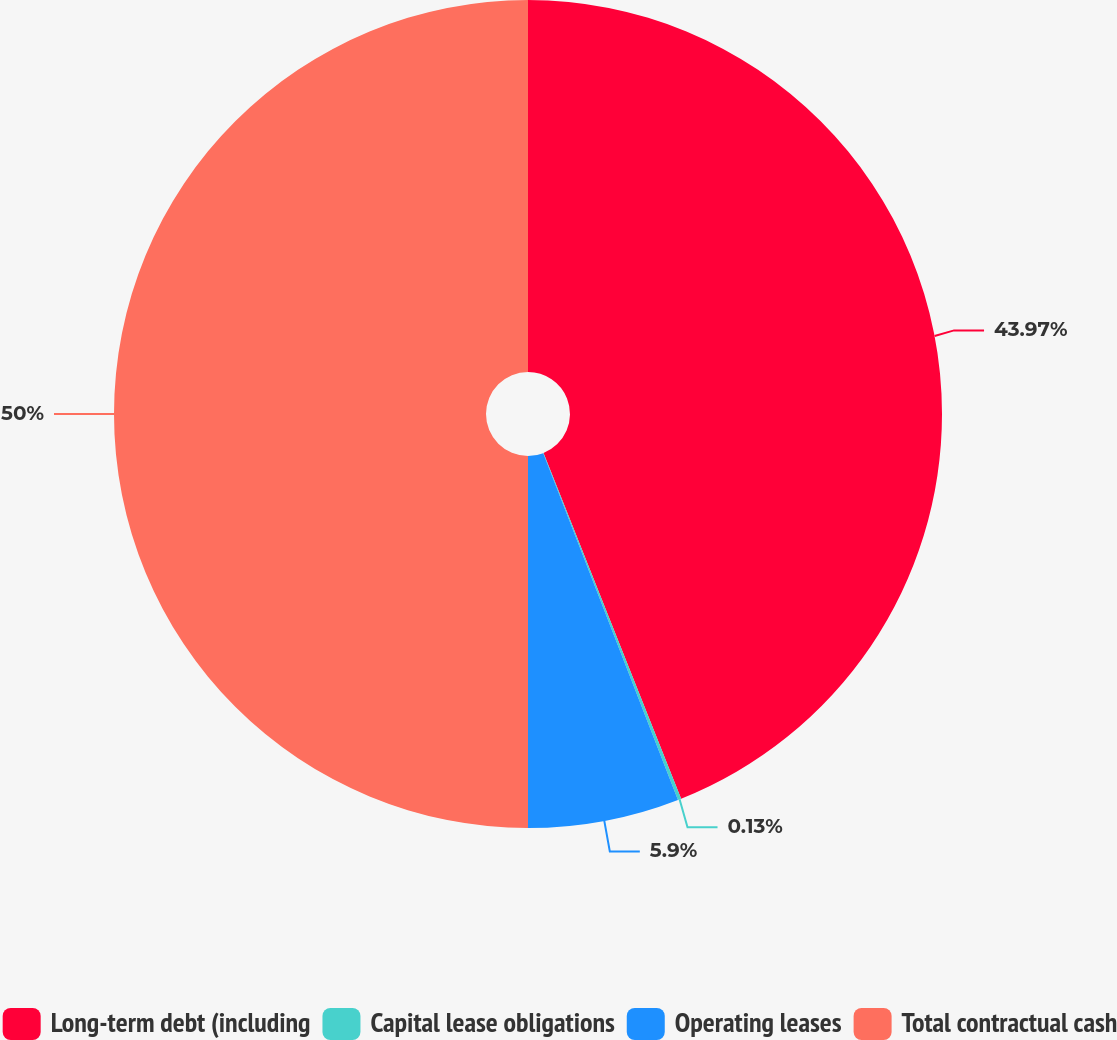Convert chart to OTSL. <chart><loc_0><loc_0><loc_500><loc_500><pie_chart><fcel>Long-term debt (including<fcel>Capital lease obligations<fcel>Operating leases<fcel>Total contractual cash<nl><fcel>43.97%<fcel>0.13%<fcel>5.9%<fcel>50.0%<nl></chart> 